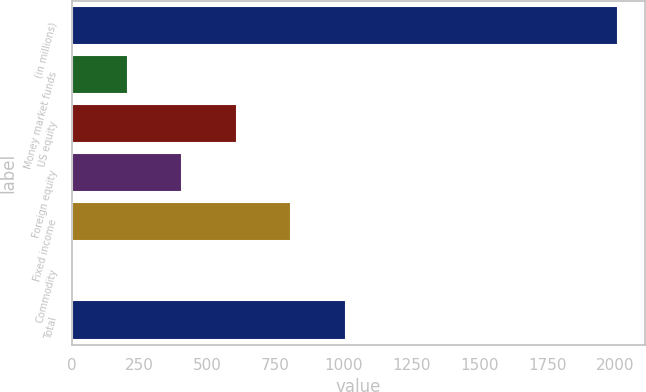Convert chart. <chart><loc_0><loc_0><loc_500><loc_500><bar_chart><fcel>(in millions)<fcel>Money market funds<fcel>US equity<fcel>Foreign equity<fcel>Fixed income<fcel>Commodity<fcel>Total<nl><fcel>2010<fcel>206.22<fcel>607.06<fcel>406.64<fcel>807.48<fcel>5.8<fcel>1007.9<nl></chart> 